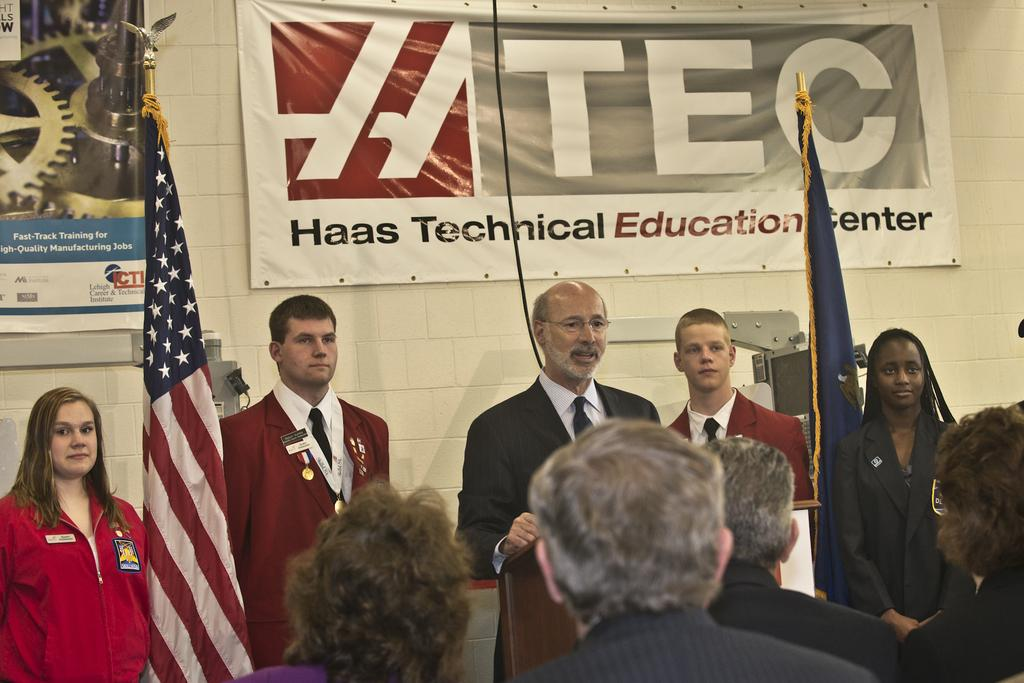What is hanging on the wall in the image? There are banners on the wall in the image. What else can be seen in the image that represents a symbol or country? There are flags in the image. What is the person in front of in the image? There is a podium in front of a person. Can you describe the people visible in the image? There are people visible in the image. How many bikes are parked on the hill in the image? There are no bikes or hills present in the image. What type of degree is the person holding in the image? There is no degree visible in the image. 